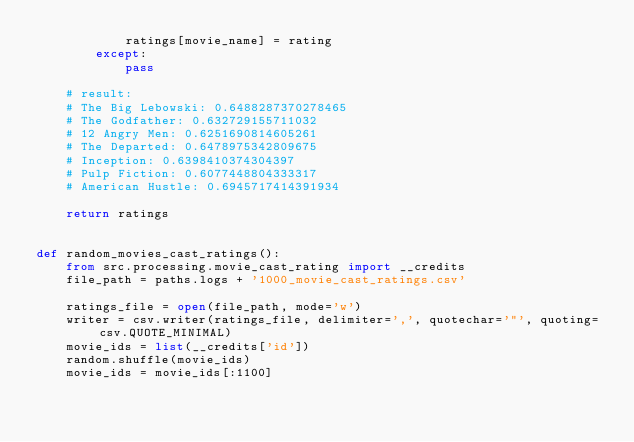Convert code to text. <code><loc_0><loc_0><loc_500><loc_500><_Python_>            ratings[movie_name] = rating
        except:
            pass

    # result:
    # The Big Lebowski: 0.6488287370278465
    # The Godfather: 0.632729155711032
    # 12 Angry Men: 0.6251690814605261
    # The Departed: 0.6478975342809675
    # Inception: 0.6398410374304397
    # Pulp Fiction: 0.6077448804333317
    # American Hustle: 0.6945717414391934

    return ratings


def random_movies_cast_ratings():
    from src.processing.movie_cast_rating import __credits
    file_path = paths.logs + '1000_movie_cast_ratings.csv'

    ratings_file = open(file_path, mode='w')
    writer = csv.writer(ratings_file, delimiter=',', quotechar='"', quoting=csv.QUOTE_MINIMAL)
    movie_ids = list(__credits['id'])
    random.shuffle(movie_ids)
    movie_ids = movie_ids[:1100]</code> 